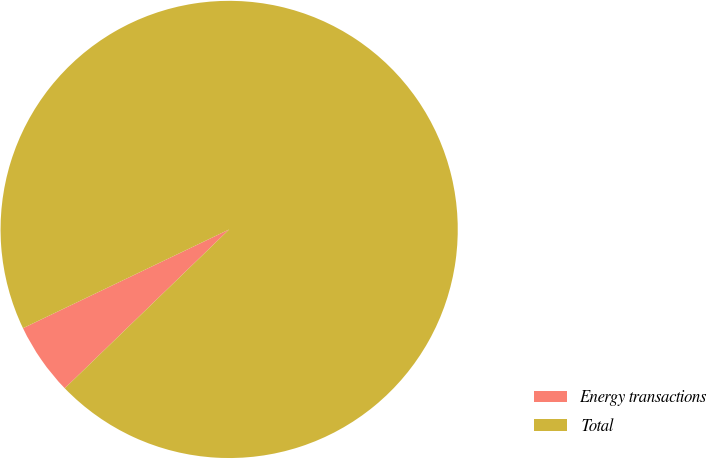<chart> <loc_0><loc_0><loc_500><loc_500><pie_chart><fcel>Energy transactions<fcel>Total<nl><fcel>5.12%<fcel>94.88%<nl></chart> 